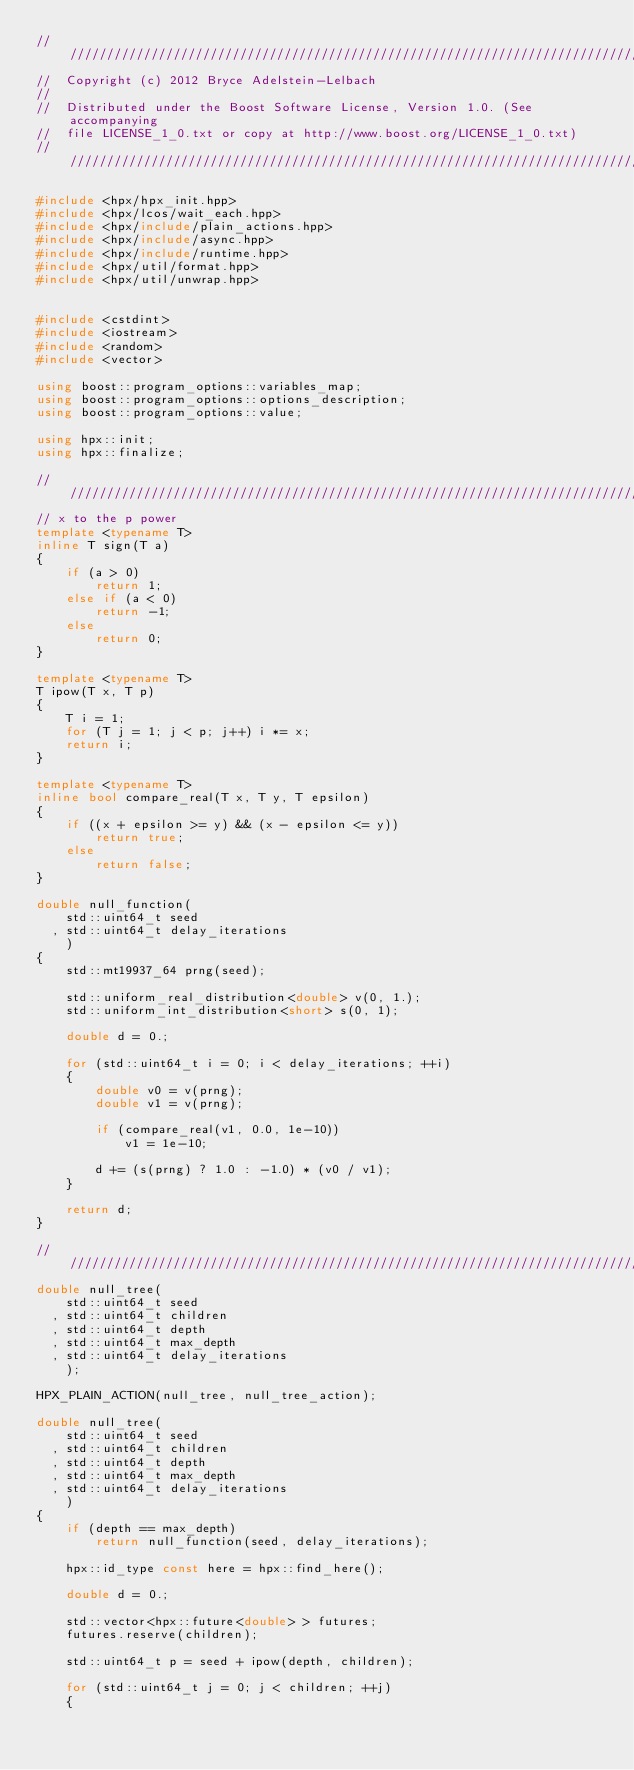Convert code to text. <code><loc_0><loc_0><loc_500><loc_500><_C++_>////////////////////////////////////////////////////////////////////////////////
//  Copyright (c) 2012 Bryce Adelstein-Lelbach
//
//  Distributed under the Boost Software License, Version 1.0. (See accompanying
//  file LICENSE_1_0.txt or copy at http://www.boost.org/LICENSE_1_0.txt)
////////////////////////////////////////////////////////////////////////////////

#include <hpx/hpx_init.hpp>
#include <hpx/lcos/wait_each.hpp>
#include <hpx/include/plain_actions.hpp>
#include <hpx/include/async.hpp>
#include <hpx/include/runtime.hpp>
#include <hpx/util/format.hpp>
#include <hpx/util/unwrap.hpp>


#include <cstdint>
#include <iostream>
#include <random>
#include <vector>

using boost::program_options::variables_map;
using boost::program_options::options_description;
using boost::program_options::value;

using hpx::init;
using hpx::finalize;

///////////////////////////////////////////////////////////////////////////////
// x to the p power
template <typename T>
inline T sign(T a)
{
    if (a > 0)
        return 1;
    else if (a < 0)
        return -1;
    else
        return 0;
}

template <typename T>
T ipow(T x, T p)
{
    T i = 1;
    for (T j = 1; j < p; j++) i *= x;
    return i;
}

template <typename T>
inline bool compare_real(T x, T y, T epsilon)
{
    if ((x + epsilon >= y) && (x - epsilon <= y))
        return true;
    else
        return false;
}

double null_function(
    std::uint64_t seed
  , std::uint64_t delay_iterations
    )
{
    std::mt19937_64 prng(seed);

    std::uniform_real_distribution<double> v(0, 1.);
    std::uniform_int_distribution<short> s(0, 1);

    double d = 0.;

    for (std::uint64_t i = 0; i < delay_iterations; ++i)
    {
        double v0 = v(prng);
        double v1 = v(prng);

        if (compare_real(v1, 0.0, 1e-10))
            v1 = 1e-10;

        d += (s(prng) ? 1.0 : -1.0) * (v0 / v1);
    }

    return d;
}

///////////////////////////////////////////////////////////////////////////////
double null_tree(
    std::uint64_t seed
  , std::uint64_t children
  , std::uint64_t depth
  , std::uint64_t max_depth
  , std::uint64_t delay_iterations
    );

HPX_PLAIN_ACTION(null_tree, null_tree_action);

double null_tree(
    std::uint64_t seed
  , std::uint64_t children
  , std::uint64_t depth
  , std::uint64_t max_depth
  , std::uint64_t delay_iterations
    )
{
    if (depth == max_depth)
        return null_function(seed, delay_iterations);

    hpx::id_type const here = hpx::find_here();

    double d = 0.;

    std::vector<hpx::future<double> > futures;
    futures.reserve(children);

    std::uint64_t p = seed + ipow(depth, children);

    for (std::uint64_t j = 0; j < children; ++j)
    {</code> 